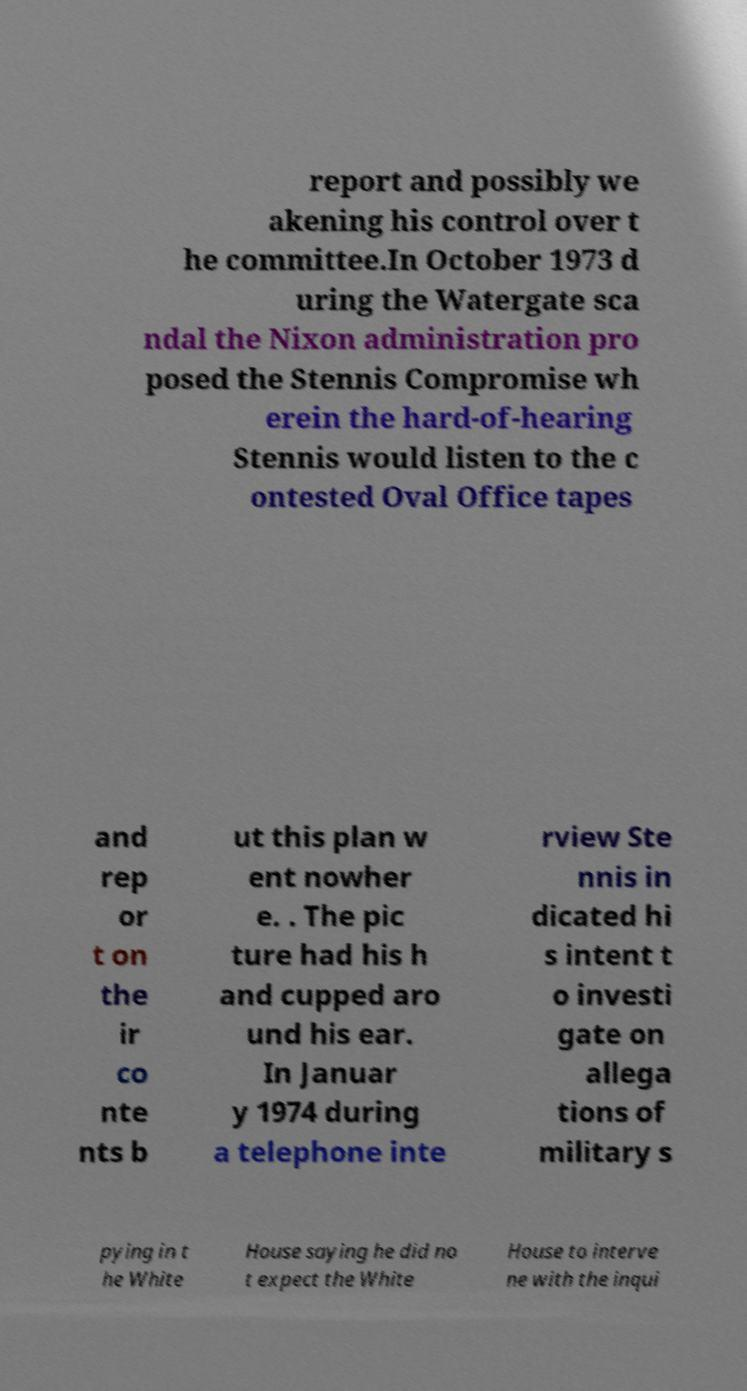Please read and relay the text visible in this image. What does it say? report and possibly we akening his control over t he committee.In October 1973 d uring the Watergate sca ndal the Nixon administration pro posed the Stennis Compromise wh erein the hard-of-hearing Stennis would listen to the c ontested Oval Office tapes and rep or t on the ir co nte nts b ut this plan w ent nowher e. . The pic ture had his h and cupped aro und his ear. In Januar y 1974 during a telephone inte rview Ste nnis in dicated hi s intent t o investi gate on allega tions of military s pying in t he White House saying he did no t expect the White House to interve ne with the inqui 